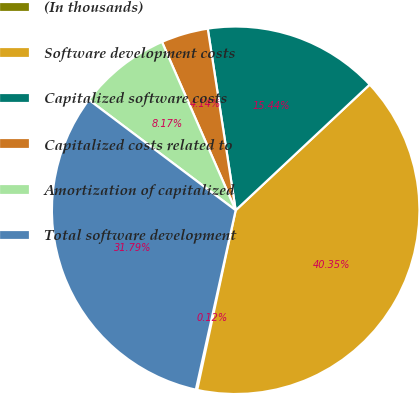Convert chart. <chart><loc_0><loc_0><loc_500><loc_500><pie_chart><fcel>(In thousands)<fcel>Software development costs<fcel>Capitalized software costs<fcel>Capitalized costs related to<fcel>Amortization of capitalized<fcel>Total software development<nl><fcel>0.12%<fcel>40.35%<fcel>15.44%<fcel>4.14%<fcel>8.17%<fcel>31.79%<nl></chart> 